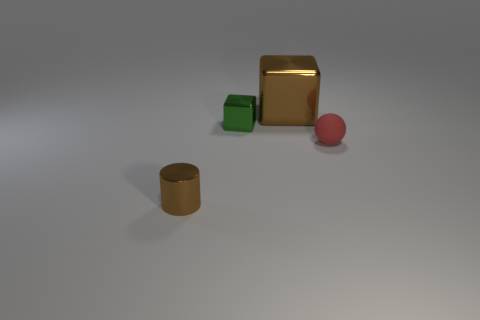Subtract all brown blocks. How many blocks are left? 1 Subtract 0 red cubes. How many objects are left? 4 Subtract all spheres. How many objects are left? 3 Subtract 1 cylinders. How many cylinders are left? 0 Subtract all gray cylinders. Subtract all red blocks. How many cylinders are left? 1 Subtract all gray balls. How many brown blocks are left? 1 Subtract all metal cubes. Subtract all brown metallic cylinders. How many objects are left? 1 Add 2 large metal things. How many large metal things are left? 3 Add 2 small red things. How many small red things exist? 3 Add 4 green objects. How many objects exist? 8 